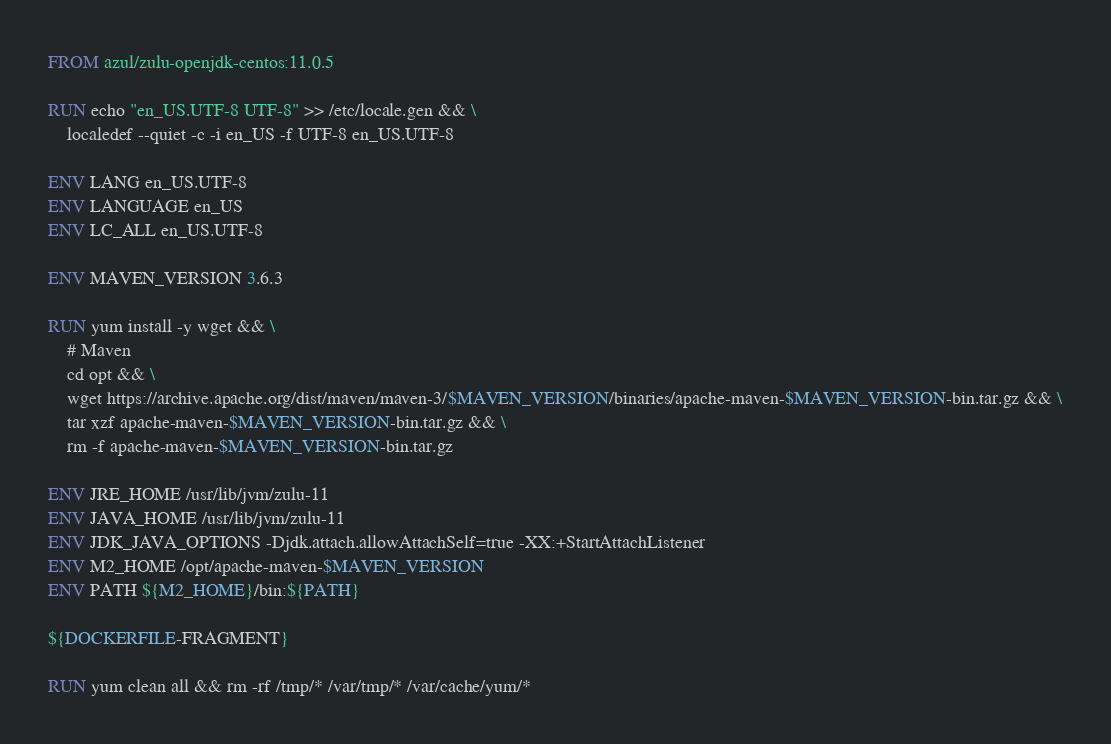<code> <loc_0><loc_0><loc_500><loc_500><_Dockerfile_>FROM azul/zulu-openjdk-centos:11.0.5

RUN echo "en_US.UTF-8 UTF-8" >> /etc/locale.gen && \
    localedef --quiet -c -i en_US -f UTF-8 en_US.UTF-8

ENV LANG en_US.UTF-8
ENV LANGUAGE en_US
ENV LC_ALL en_US.UTF-8

ENV MAVEN_VERSION 3.6.3

RUN yum install -y wget && \
    # Maven
    cd opt && \
    wget https://archive.apache.org/dist/maven/maven-3/$MAVEN_VERSION/binaries/apache-maven-$MAVEN_VERSION-bin.tar.gz && \
    tar xzf apache-maven-$MAVEN_VERSION-bin.tar.gz && \
    rm -f apache-maven-$MAVEN_VERSION-bin.tar.gz

ENV JRE_HOME /usr/lib/jvm/zulu-11
ENV JAVA_HOME /usr/lib/jvm/zulu-11
ENV JDK_JAVA_OPTIONS -Djdk.attach.allowAttachSelf=true -XX:+StartAttachListener
ENV M2_HOME /opt/apache-maven-$MAVEN_VERSION
ENV PATH ${M2_HOME}/bin:${PATH}

${DOCKERFILE-FRAGMENT}

RUN yum clean all && rm -rf /tmp/* /var/tmp/* /var/cache/yum/*</code> 